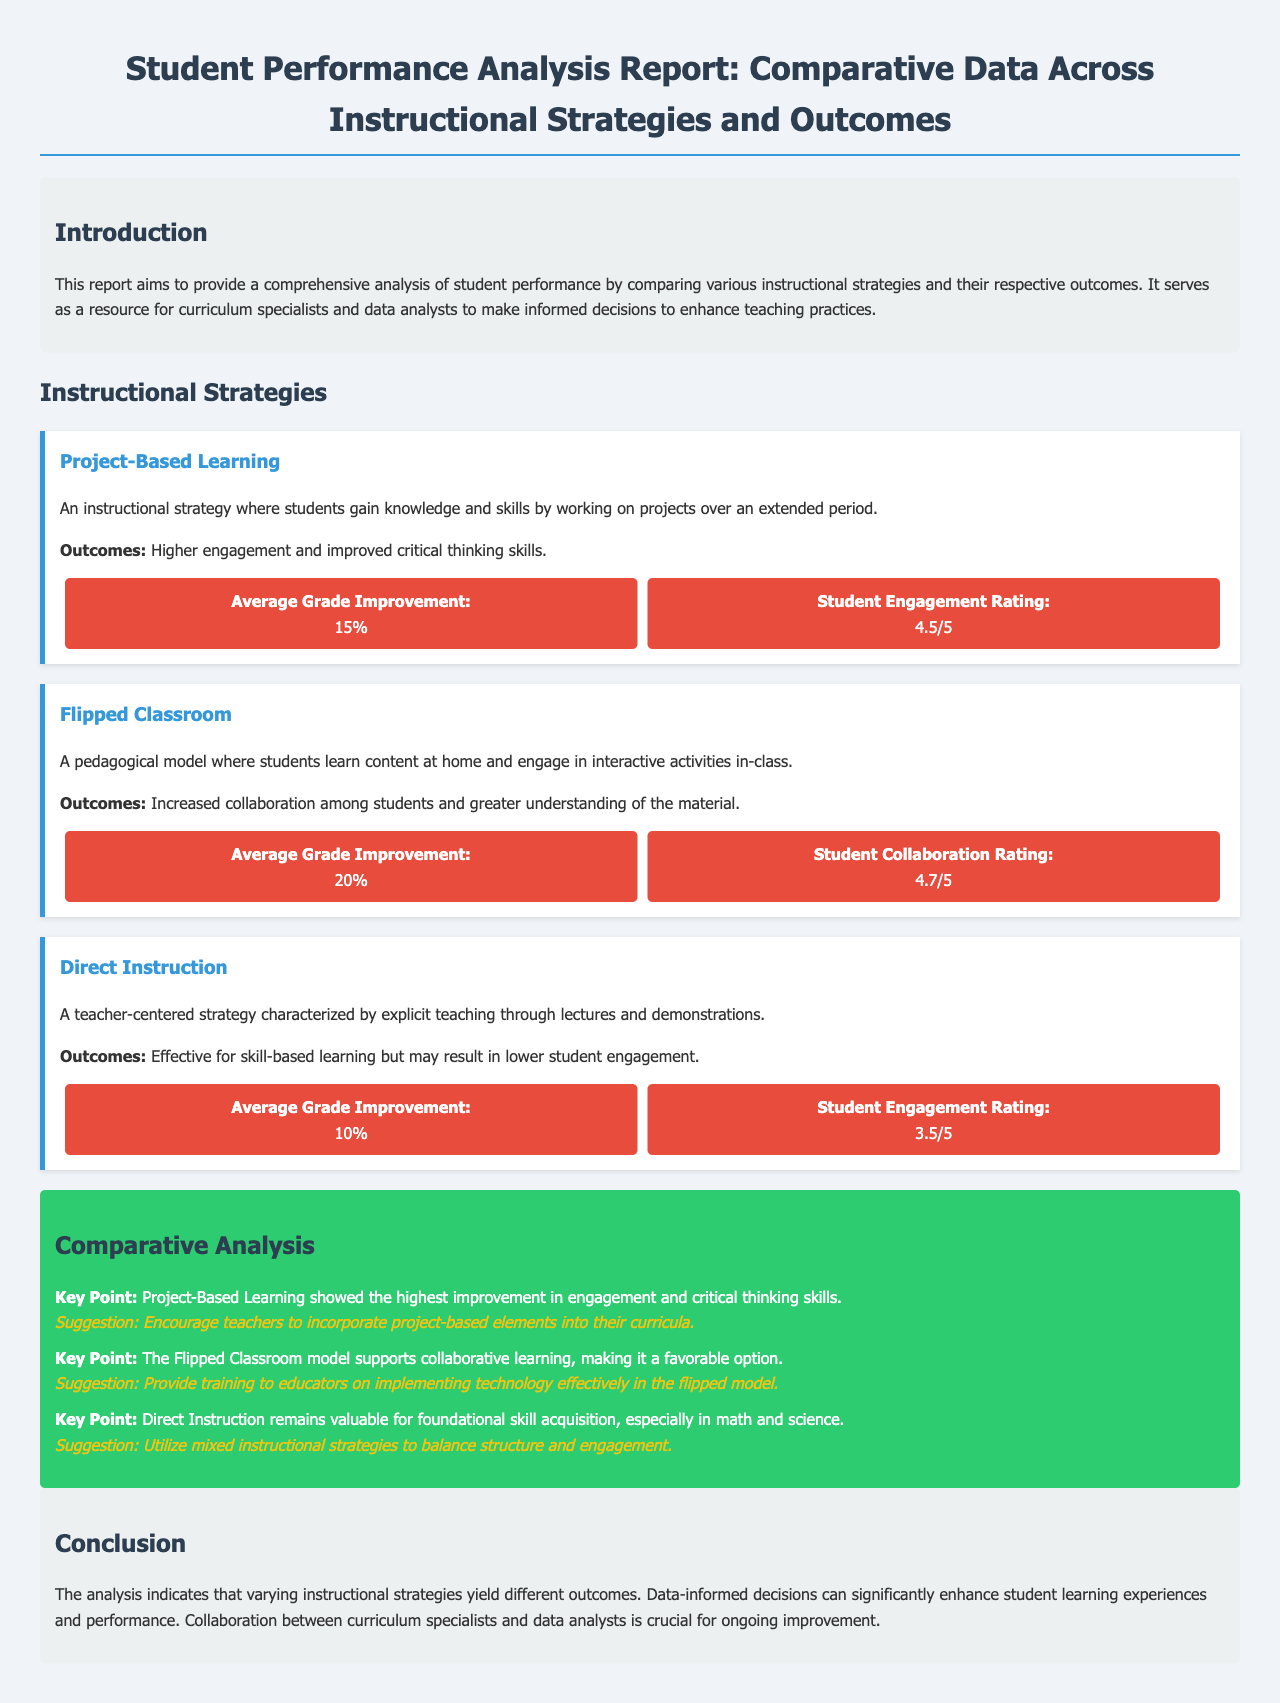What is the average grade improvement for Project-Based Learning? The average grade improvement for Project-Based Learning is listed as 15%.
Answer: 15% What rating did students give for Flipped Classroom collaboration? The Student Collaboration Rating for Flipped Classroom is given as 4.7 out of 5.
Answer: 4.7/5 Which instructional strategy has the lowest engagement rating? The engagement rating for Direct Instruction is lower than others, stated as 3.5 out of 5.
Answer: 3.5/5 What is the main outcome of Project-Based Learning? The main outcome of Project-Based Learning is higher engagement and improved critical thinking skills.
Answer: Higher engagement and improved critical thinking skills What suggestion is made for Direct Instruction? The suggestion for Direct Instruction is to utilize mixed instructional strategies to balance structure and engagement.
Answer: Utilize mixed instructional strategies to balance structure and engagement What color is the background of the conclusion section? The conclusion section has a background color of light gray as noted by the coding.
Answer: Light gray What is the main goal of the report? The main goal of the report is to provide a comprehensive analysis of student performance comparing instructional strategies and outcomes.
Answer: To provide a comprehensive analysis of student performance How is the data presented visually in the report? The data is presented using flexbox for better alignment and visibility.
Answer: Using flexbox What is suggested for teachers to enhance Project-Based Learning? The report suggests encouraging teachers to incorporate project-based elements into their curricula.
Answer: Encourage teachers to incorporate project-based elements 